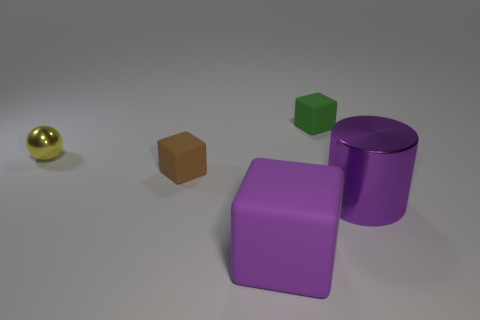Could you infer the relative sizes of these objects? Do they seem life-size or miniature? The sizes of the objects seem consistent with each other, suggesting they could be miniature models used for educational or illustrative purposes. None appear to be life-size, and the relative scale between them suggests they could be prototypes or 3D printed models used to study shapes and spatial relationships. 